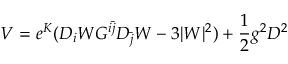<formula> <loc_0><loc_0><loc_500><loc_500>V = e ^ { K } ( D _ { i } W G ^ { i \bar { j } } D _ { \bar { j } } W - 3 | W | ^ { 2 } ) + { \frac { 1 } { 2 } } g ^ { 2 } D ^ { 2 }</formula> 